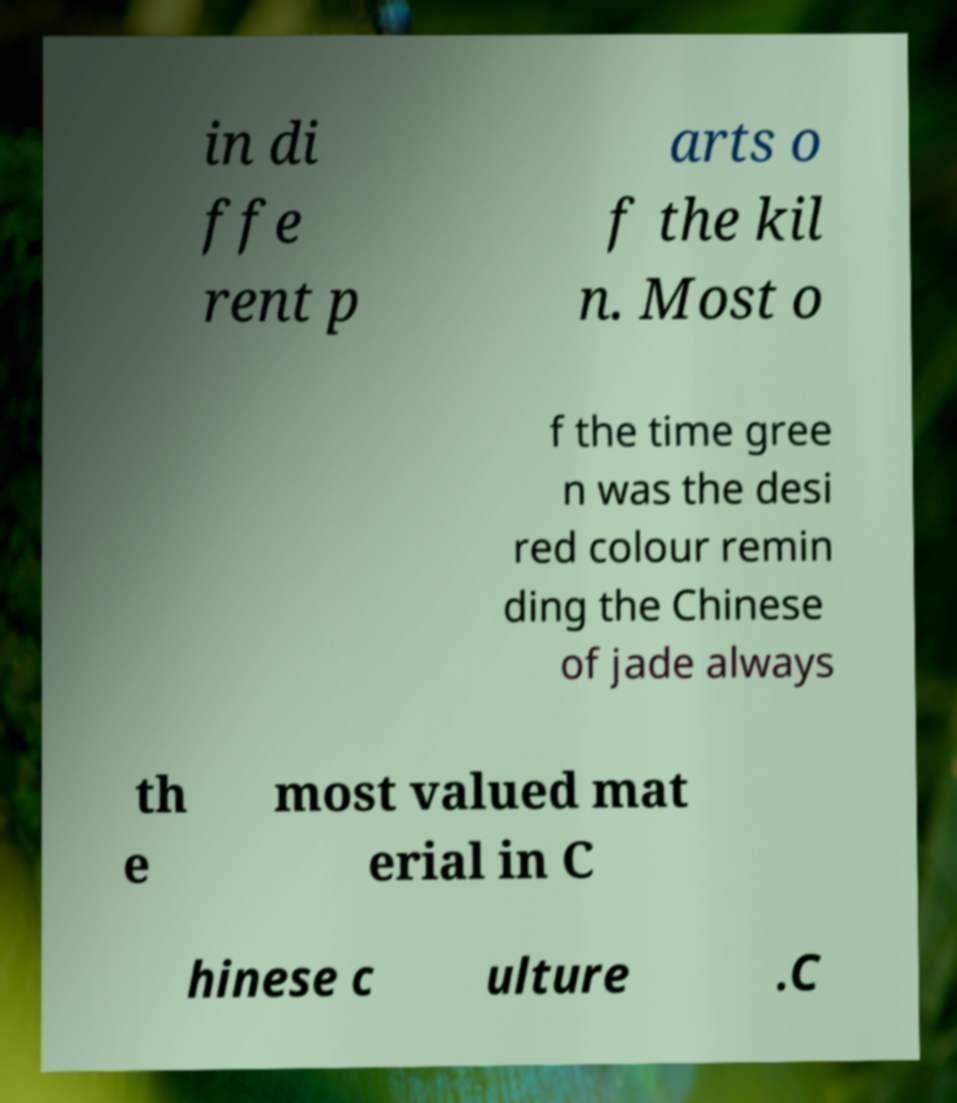What messages or text are displayed in this image? I need them in a readable, typed format. in di ffe rent p arts o f the kil n. Most o f the time gree n was the desi red colour remin ding the Chinese of jade always th e most valued mat erial in C hinese c ulture .C 